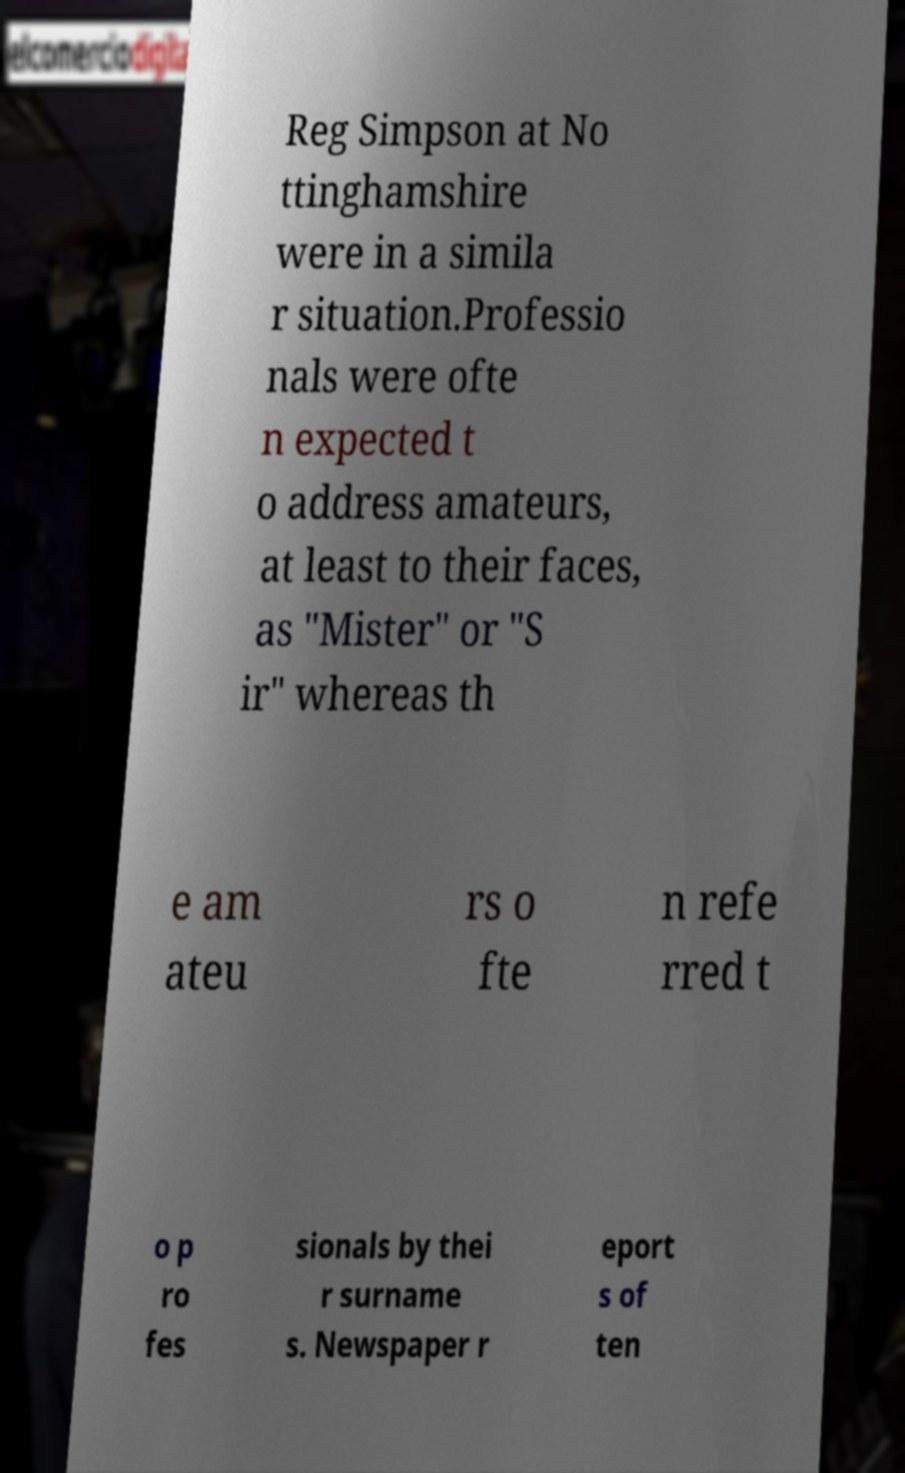What messages or text are displayed in this image? I need them in a readable, typed format. Reg Simpson at No ttinghamshire were in a simila r situation.Professio nals were ofte n expected t o address amateurs, at least to their faces, as "Mister" or "S ir" whereas th e am ateu rs o fte n refe rred t o p ro fes sionals by thei r surname s. Newspaper r eport s of ten 